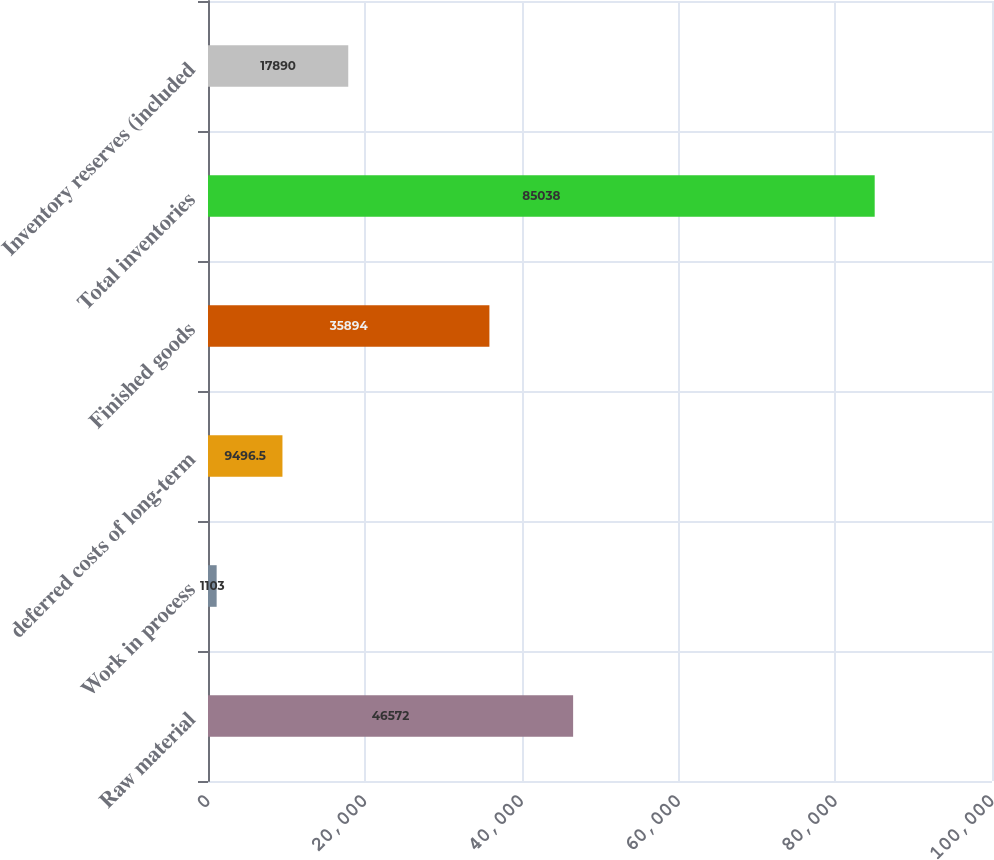Convert chart. <chart><loc_0><loc_0><loc_500><loc_500><bar_chart><fcel>Raw material<fcel>Work in process<fcel>deferred costs of long-term<fcel>Finished goods<fcel>Total inventories<fcel>Inventory reserves (included<nl><fcel>46572<fcel>1103<fcel>9496.5<fcel>35894<fcel>85038<fcel>17890<nl></chart> 